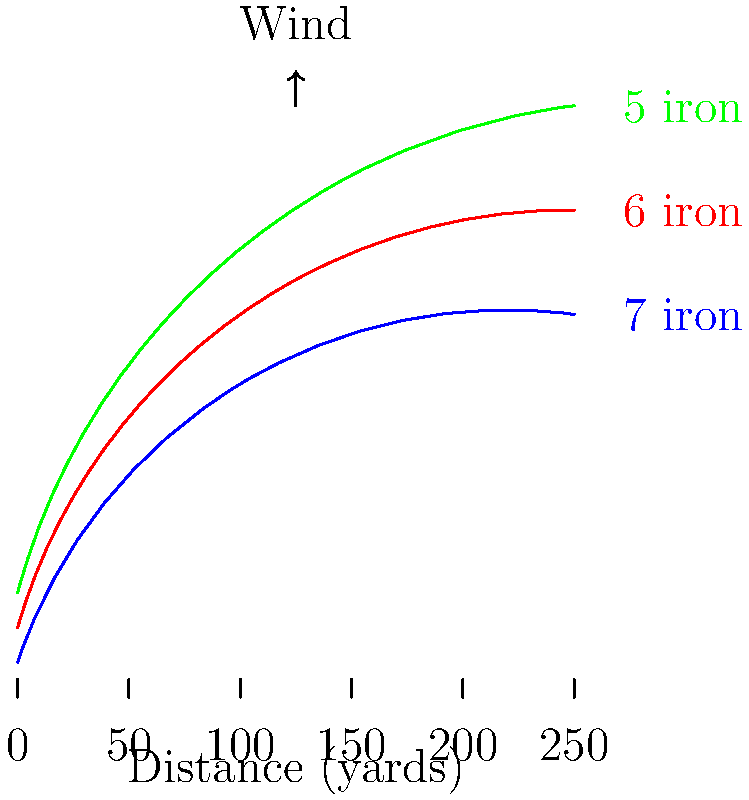Based on Paul Broadhurst's typical club distances and the wind conditions shown in the graph, which iron would be the optimal choice for a shot to a pin 165 yards away? To determine the optimal club choice, we need to analyze the graph and consider the following steps:

1. Identify the target distance: 165 yards

2. Observe the wind direction: The arrow indicates a headwind, which will reduce the effective distance of each club.

3. Analyze the club distance curves:
   - Blue curve: 7 iron
   - Red curve: 6 iron
   - Green curve: 5 iron

4. Consider the headwind effect:
   - The headwind will decrease the distance each club can achieve.
   - We need to choose a club that typically hits farther than our target distance to compensate for the wind.

5. Evaluate each club option:
   - 7 iron (blue curve): Reaches about 150 yards without wind, which is insufficient.
   - 6 iron (red curve): Reaches about 165 yards without wind, which might be just short with the headwind.
   - 5 iron (green curve): Reaches about 180 yards without wind, providing extra distance to counter the headwind.

6. Make the decision:
   The 5 iron (green curve) is the optimal choice as it provides enough extra distance to compensate for the headwind while reaching the target distance of 165 yards.
Answer: 5 iron 